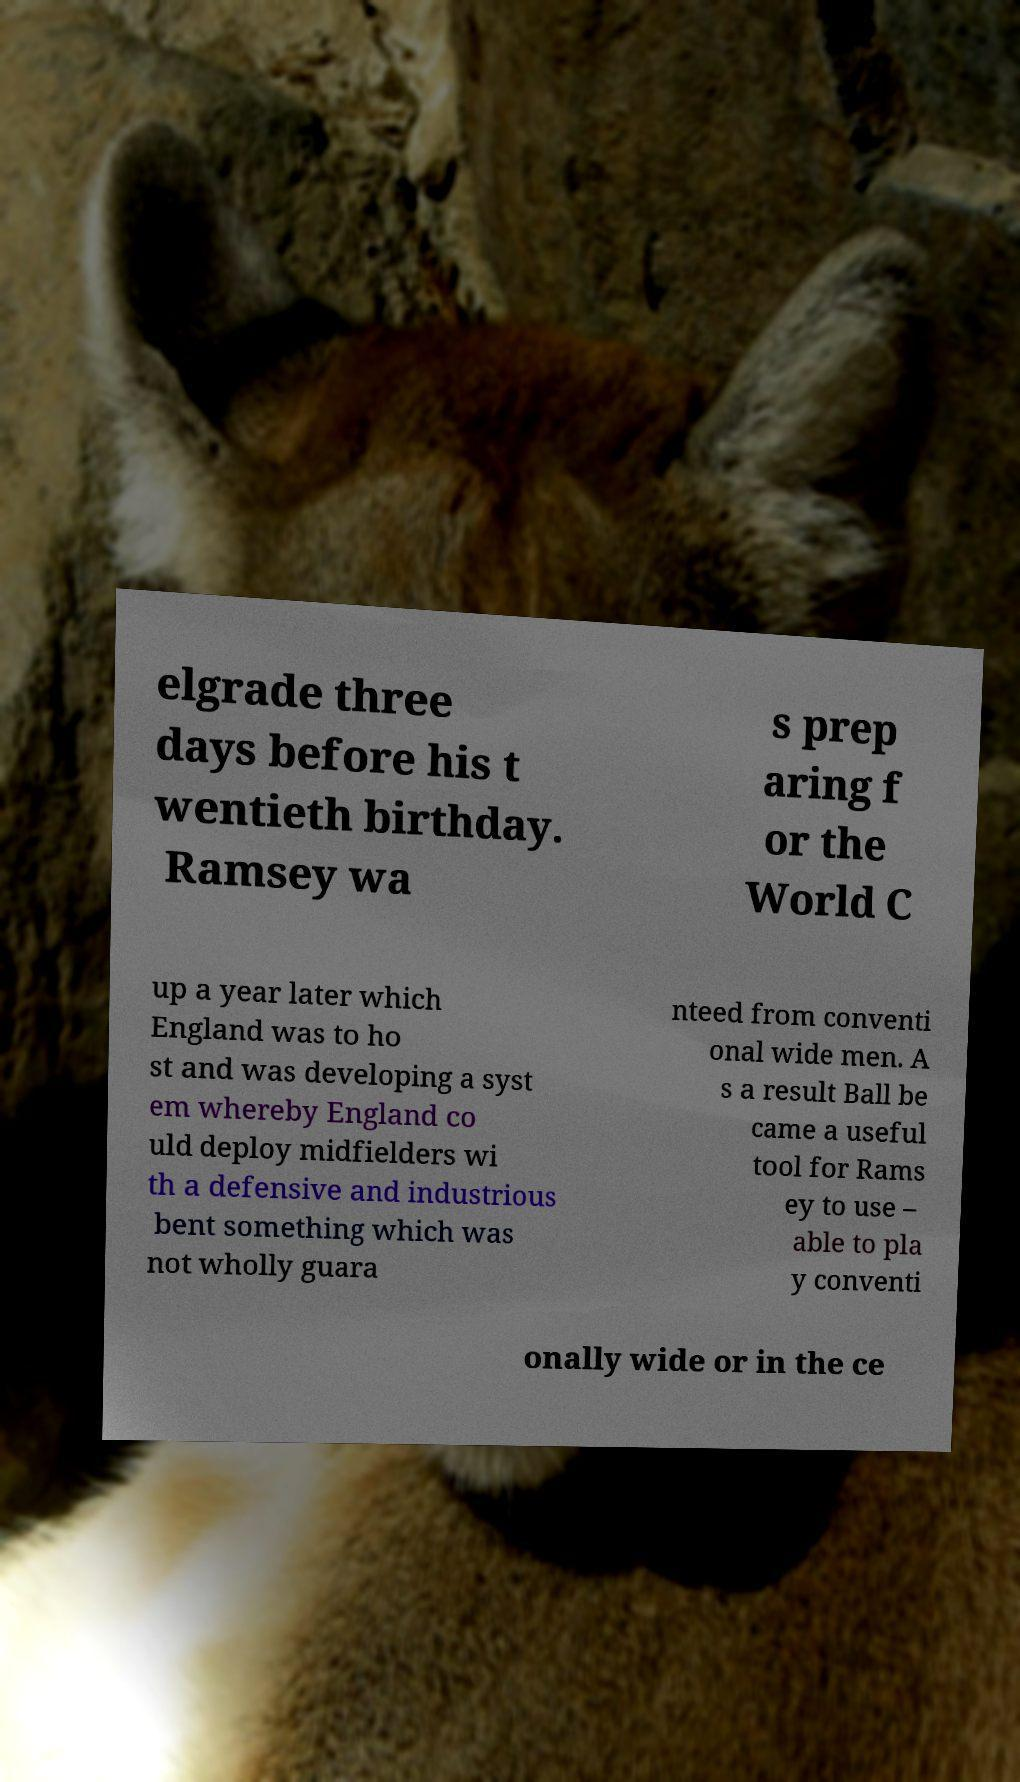Please identify and transcribe the text found in this image. elgrade three days before his t wentieth birthday. Ramsey wa s prep aring f or the World C up a year later which England was to ho st and was developing a syst em whereby England co uld deploy midfielders wi th a defensive and industrious bent something which was not wholly guara nteed from conventi onal wide men. A s a result Ball be came a useful tool for Rams ey to use – able to pla y conventi onally wide or in the ce 